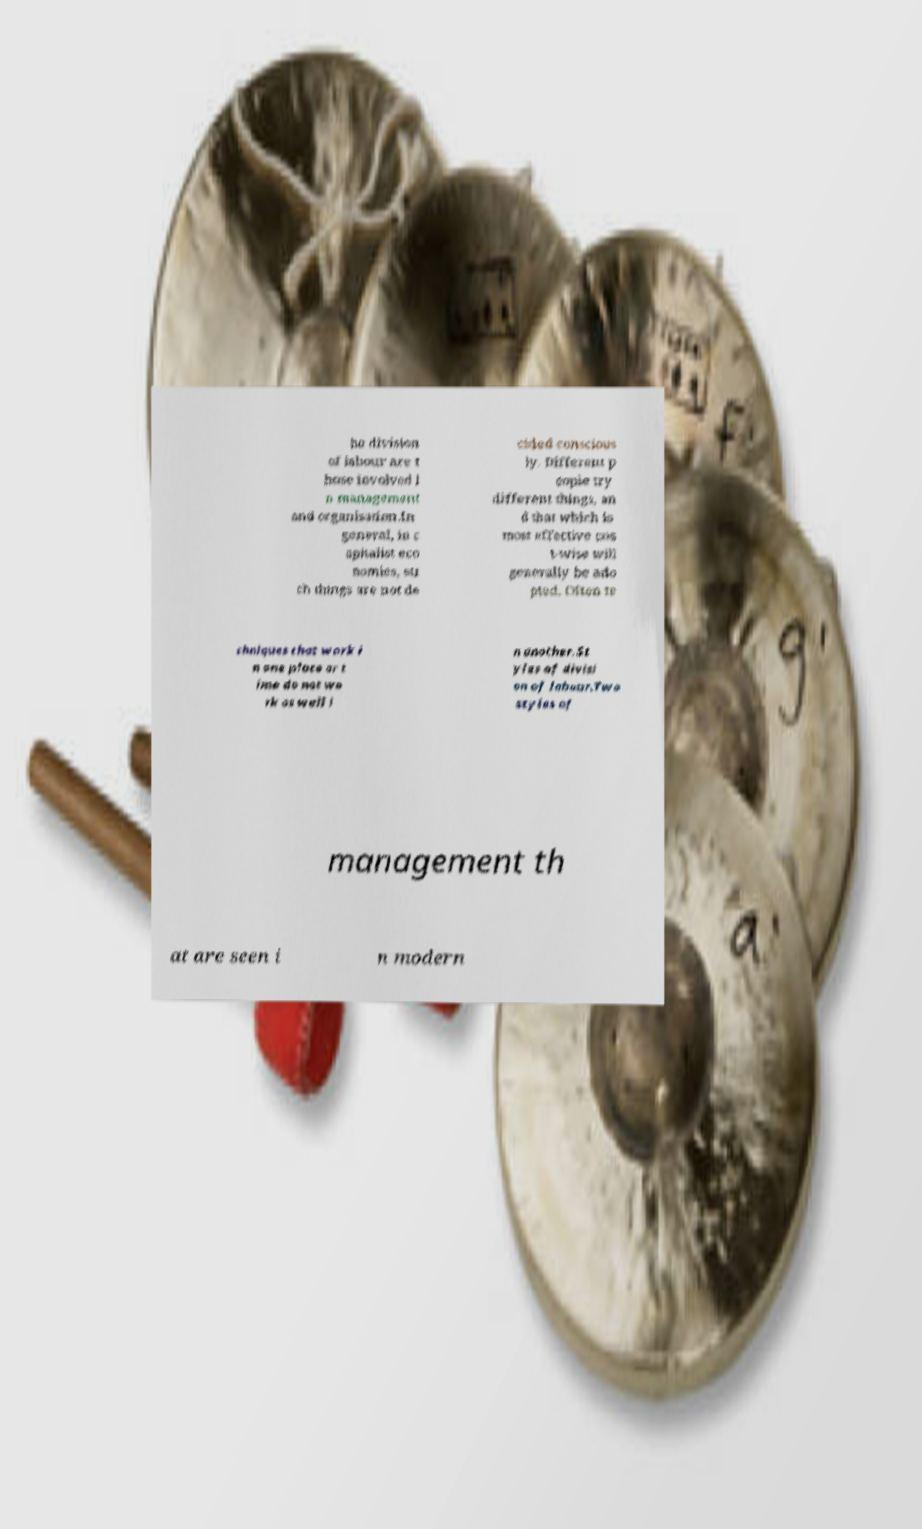Please identify and transcribe the text found in this image. he division of labour are t hose involved i n management and organisation.In general, in c apitalist eco nomies, su ch things are not de cided conscious ly. Different p eople try different things, an d that which is most effective cos t-wise will generally be ado pted. Often te chniques that work i n one place or t ime do not wo rk as well i n another.St yles of divisi on of labour.Two styles of management th at are seen i n modern 